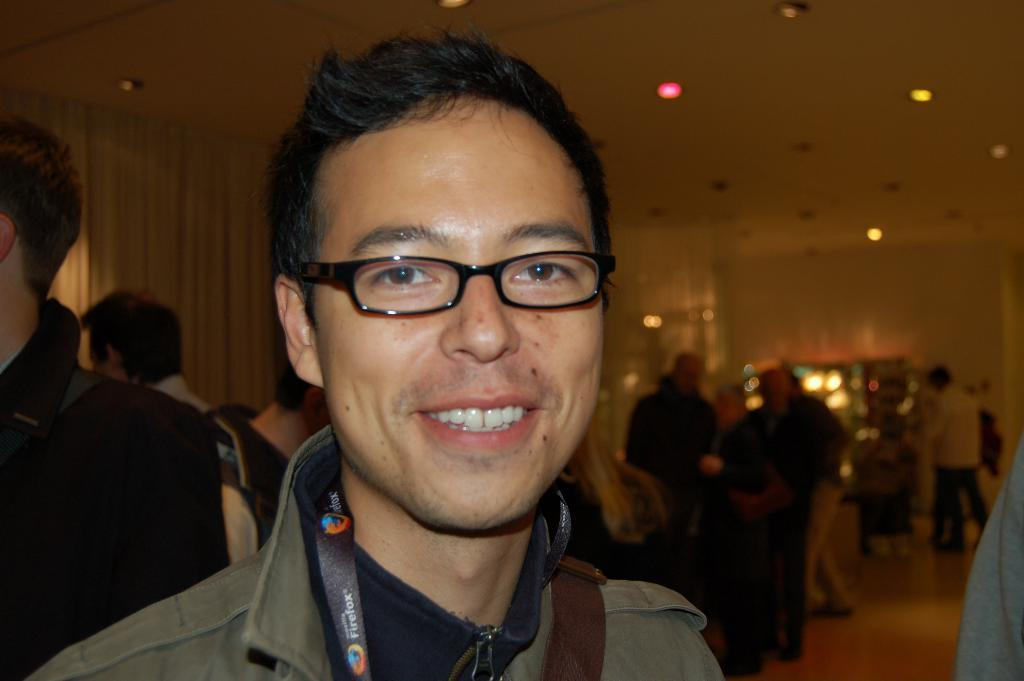What is the man in the image doing? The man is standing in the image and smiling. Can you describe the people in the background of the image? There are people in the background of the image, but their specific actions or appearances are not mentioned in the facts. What is the purpose of the curtain in the image? The purpose of the curtain is not mentioned in the facts, but it is visible in the image. What type of structure is depicted in the image? The image shows a roof, which suggests that the man is indoors or under a shelter. What can be seen illuminated in the image? There are lights visible in the image, which may indicate that the scene is well-lit or that the lights serve a specific purpose. What type of jam is being served on the cup in the image? There is no jam or cup present in the image; the facts mention a man, people in the background, a curtain, a roof, and lights. 